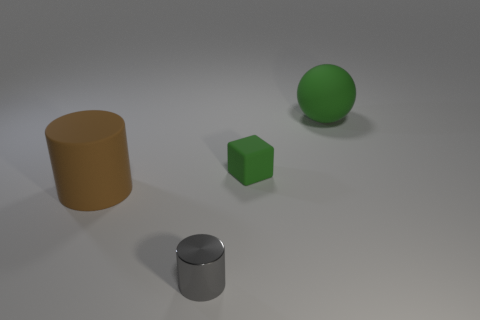Subtract all gray cylinders. Subtract all brown spheres. How many cylinders are left? 1 Add 2 small gray shiny cylinders. How many objects exist? 6 Subtract all spheres. How many objects are left? 3 Add 4 red blocks. How many red blocks exist? 4 Subtract 0 purple blocks. How many objects are left? 4 Subtract all small green matte cubes. Subtract all big brown rubber objects. How many objects are left? 2 Add 1 blocks. How many blocks are left? 2 